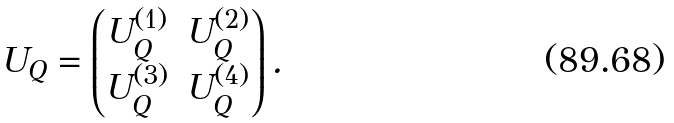Convert formula to latex. <formula><loc_0><loc_0><loc_500><loc_500>U _ { Q } = \begin{pmatrix} U _ { Q } ^ { ( 1 ) } & U _ { Q } ^ { ( 2 ) } \\ U _ { Q } ^ { ( 3 ) } & U _ { Q } ^ { ( 4 ) } \end{pmatrix} .</formula> 